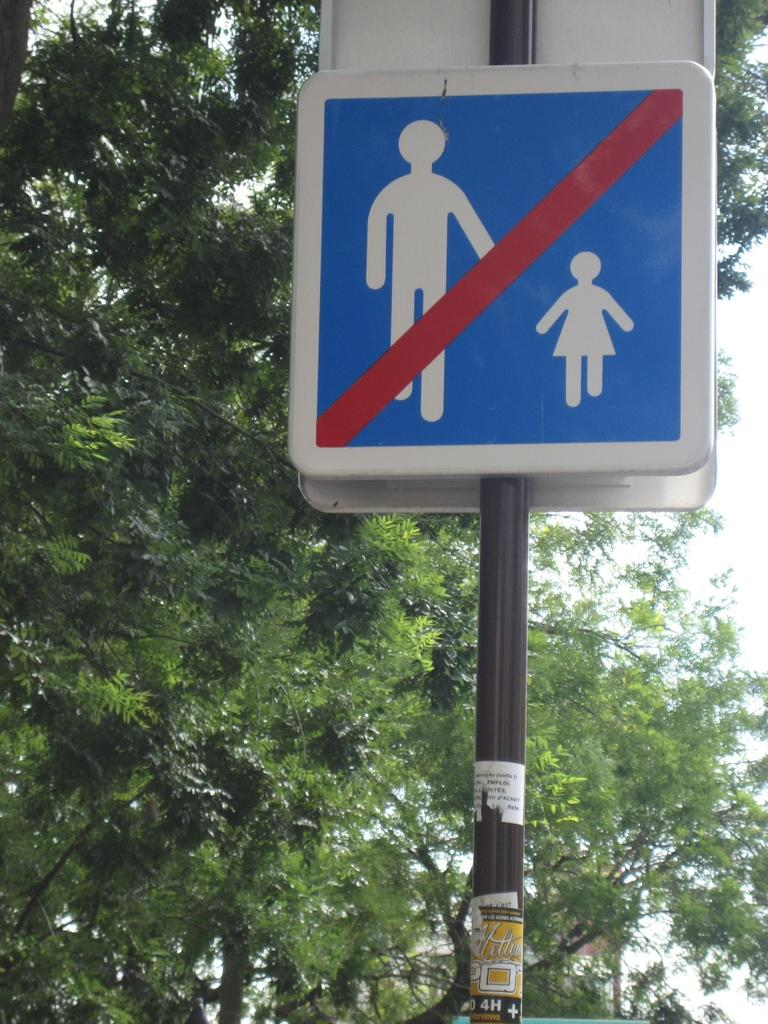What can be seen on the sign boards in the image? There are sign boards with pictures in the image. Where are the sign boards located? The sign boards are placed on a pole. What can be seen in the background of the image? There is a group of trees and the sky visible in the background of the image. What type of bell can be heard ringing in the image? There is no bell present in the image, and therefore no sound can be heard. 